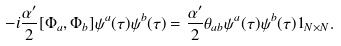Convert formula to latex. <formula><loc_0><loc_0><loc_500><loc_500>- i \frac { \alpha ^ { \prime } } { 2 } [ \Phi _ { a } , \Phi _ { b } ] \psi ^ { a } ( \tau ) \psi ^ { b } ( \tau ) = \frac { \alpha ^ { \prime } } { 2 } \theta _ { a b } \psi ^ { a } ( \tau ) \psi ^ { b } ( \tau ) 1 _ { N \times N } .</formula> 